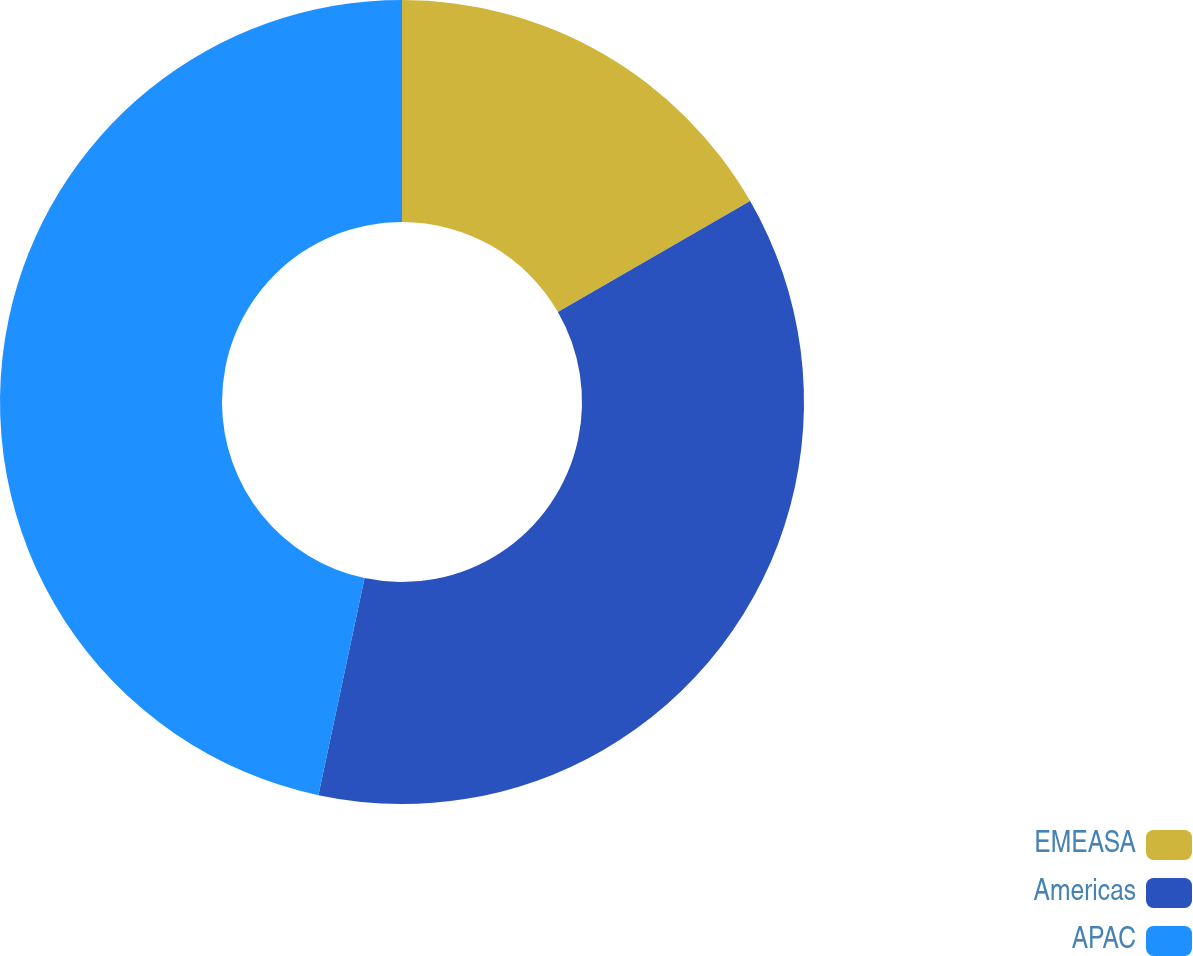Convert chart to OTSL. <chart><loc_0><loc_0><loc_500><loc_500><pie_chart><fcel>EMEASA<fcel>Americas<fcel>APAC<nl><fcel>16.67%<fcel>36.67%<fcel>46.67%<nl></chart> 